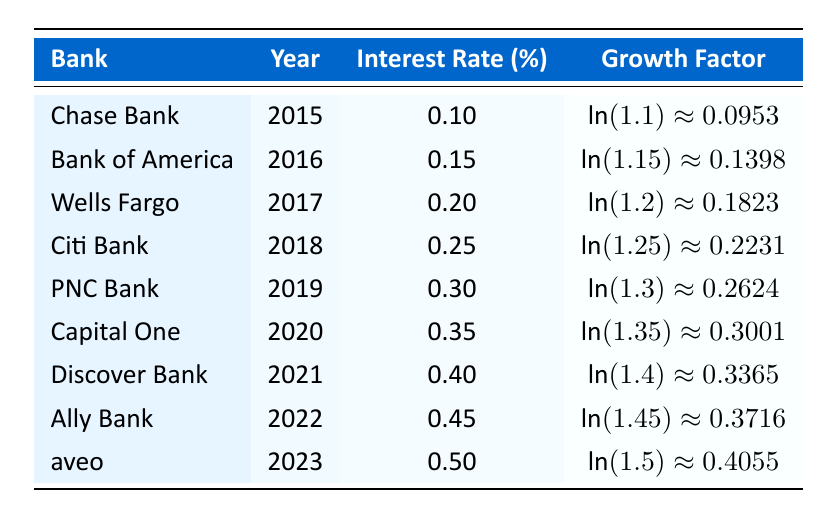What is the interest rate for Wells Fargo in 2017? The table lists the interest rates for each bank by year. For Wells Fargo, the year is 2017 and the interest rate is 0.2.
Answer: 0.2 Which bank had the highest interest rate in 2023? The table shows that in 2023, aveo had an interest rate of 0.5, which is the highest compared to the other banks listed.
Answer: aveo What is the growth factor for Chase Bank in 2015? The table indicates that for Chase Bank in 2015, the growth factor is 1.1 as denoted in the relevant row.
Answer: 1.1 What is the average interest rate from 2015 to 2023? To calculate the average, sum the interest rates (0.1 + 0.15 + 0.2 + 0.25 + 0.3 + 0.35 + 0.4 + 0.45 + 0.5 = 2.1) and divide by the number of years (9). The average interest rate is 2.1 / 9 ≈ 0.2333.
Answer: 0.2333 Is the growth factor for Citi Bank larger than 1.2? According to the table, the growth factor for Citi Bank in 2018 is 1.25, which is indeed larger than 1.2.
Answer: Yes What is the growth difference between PNC Bank in 2019 and Discover Bank in 2021? The growth factor for PNC Bank is 1.3 and for Discover Bank is 1.4. The difference is calculated as 1.4 - 1.3 = 0.1.
Answer: 0.1 Which bank has the lowest growth factor in the table? By reviewing the table, the lowest growth factor is attributed to Chase Bank in 2015, which is 1.1.
Answer: Chase Bank How many banks have an interest rate of 0.4 or higher? The banks with an interest rate of 0.4 or higher are Discover Bank (0.4), Ally Bank (0.45), and aveo (0.5). Therefore, there are three banks.
Answer: 3 What is the total growth factor of all banks from 2015 to 2023? Each growth factor is summed (1.1 + 1.15 + 1.2 + 1.25 + 1.3 + 1.35 + 1.4 + 1.45 + 1.5 = 11.85) to determine the total growth factor across all listed banks.
Answer: 11.85 